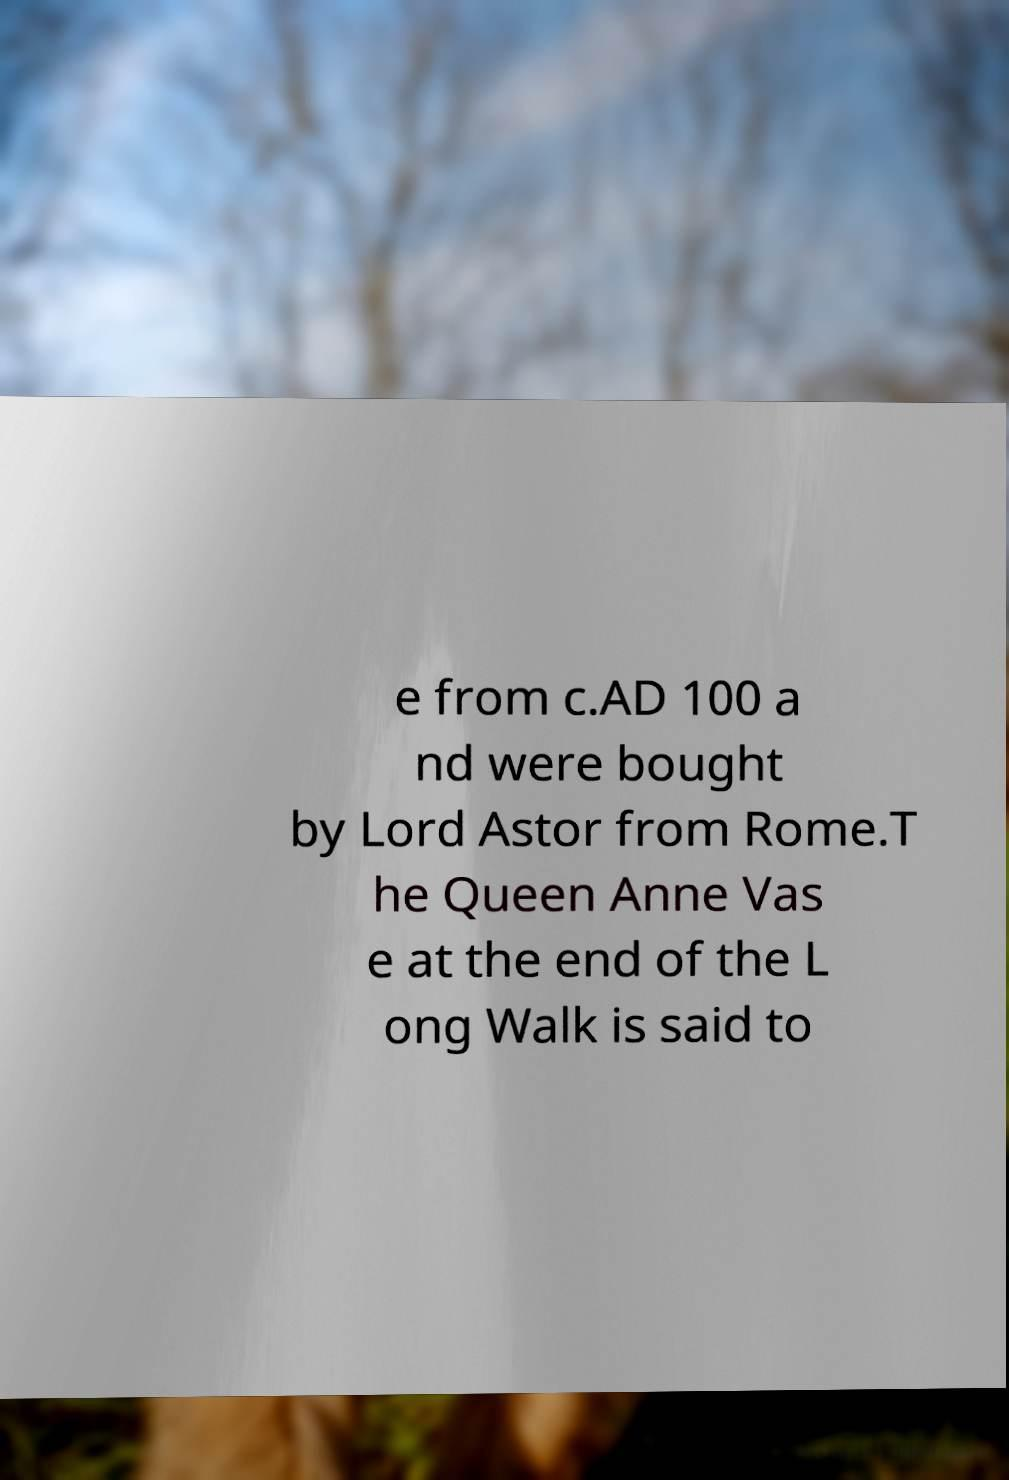What messages or text are displayed in this image? I need them in a readable, typed format. e from c.AD 100 a nd were bought by Lord Astor from Rome.T he Queen Anne Vas e at the end of the L ong Walk is said to 